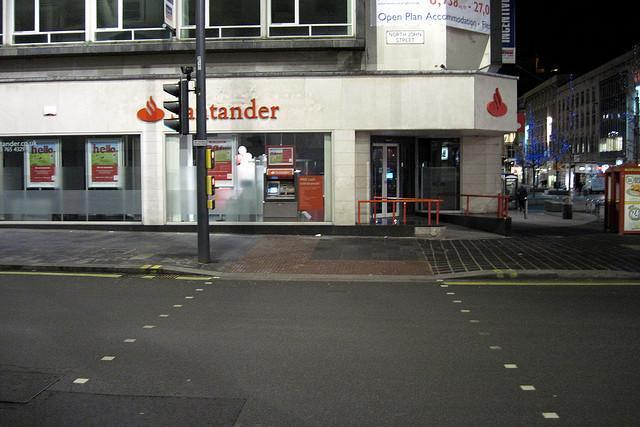What might come from the right or left at any time?
Choose the right answer from the provided options to respond to the question.
Options: Lava, train, tank, car. Car. 